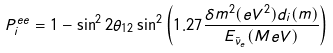Convert formula to latex. <formula><loc_0><loc_0><loc_500><loc_500>P ^ { e e } _ { i } = 1 - \sin ^ { 2 } 2 \theta _ { 1 2 } \sin ^ { 2 } \left ( 1 . 2 7 \frac { \delta m ^ { 2 } ( e V ^ { 2 } ) d _ { i } ( m ) } { E _ { \bar { \nu } _ { e } } ( M e V ) } \right ) \,</formula> 